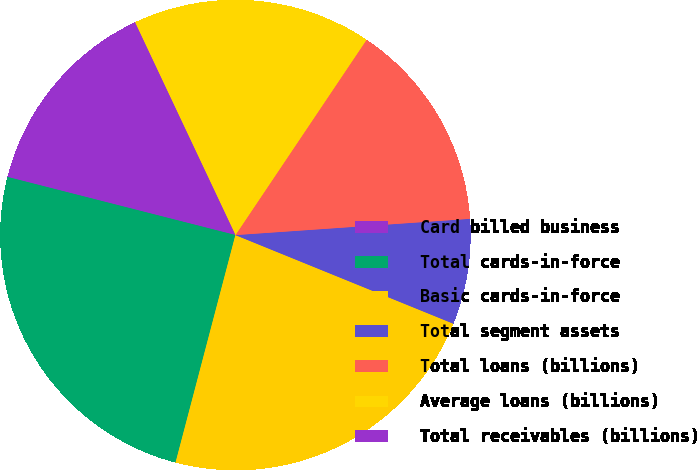Convert chart. <chart><loc_0><loc_0><loc_500><loc_500><pie_chart><fcel>Card billed business<fcel>Total cards-in-force<fcel>Basic cards-in-force<fcel>Total segment assets<fcel>Total loans (billions)<fcel>Average loans (billions)<fcel>Total receivables (billions)<nl><fcel>9.18%<fcel>24.88%<fcel>22.95%<fcel>7.25%<fcel>14.49%<fcel>16.43%<fcel>4.83%<nl></chart> 